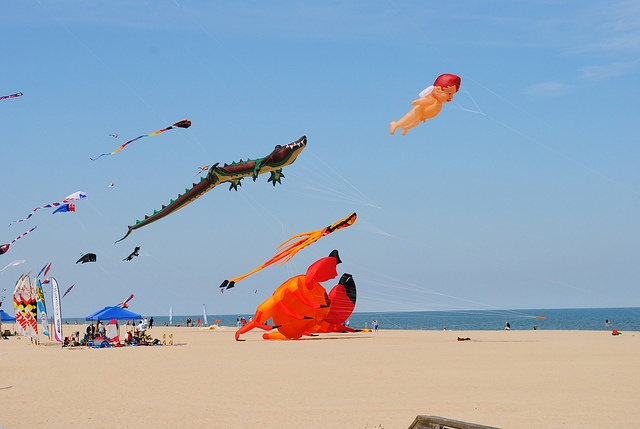Describe the objects in this image and their specific colors. I can see kite in darkgray, lightblue, tan, and gray tones, kite in darkgray, red, brown, and black tones, kite in darkgray, black, maroon, olive, and lightblue tones, kite in darkgray, tan, red, and salmon tones, and kite in darkgray, lightblue, and lavender tones in this image. 